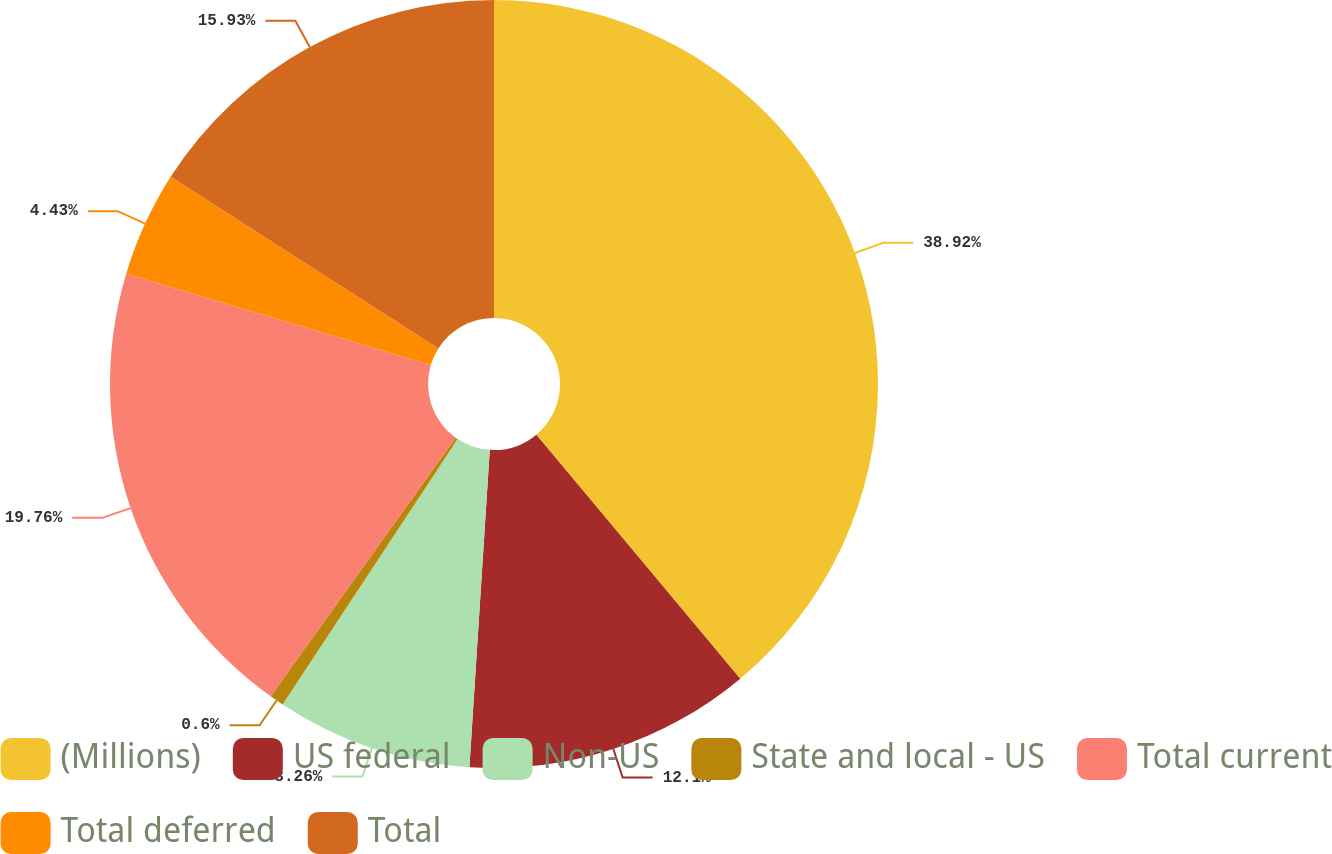<chart> <loc_0><loc_0><loc_500><loc_500><pie_chart><fcel>(Millions)<fcel>US federal<fcel>Non-US<fcel>State and local - US<fcel>Total current<fcel>Total deferred<fcel>Total<nl><fcel>38.92%<fcel>12.1%<fcel>8.26%<fcel>0.6%<fcel>19.76%<fcel>4.43%<fcel>15.93%<nl></chart> 